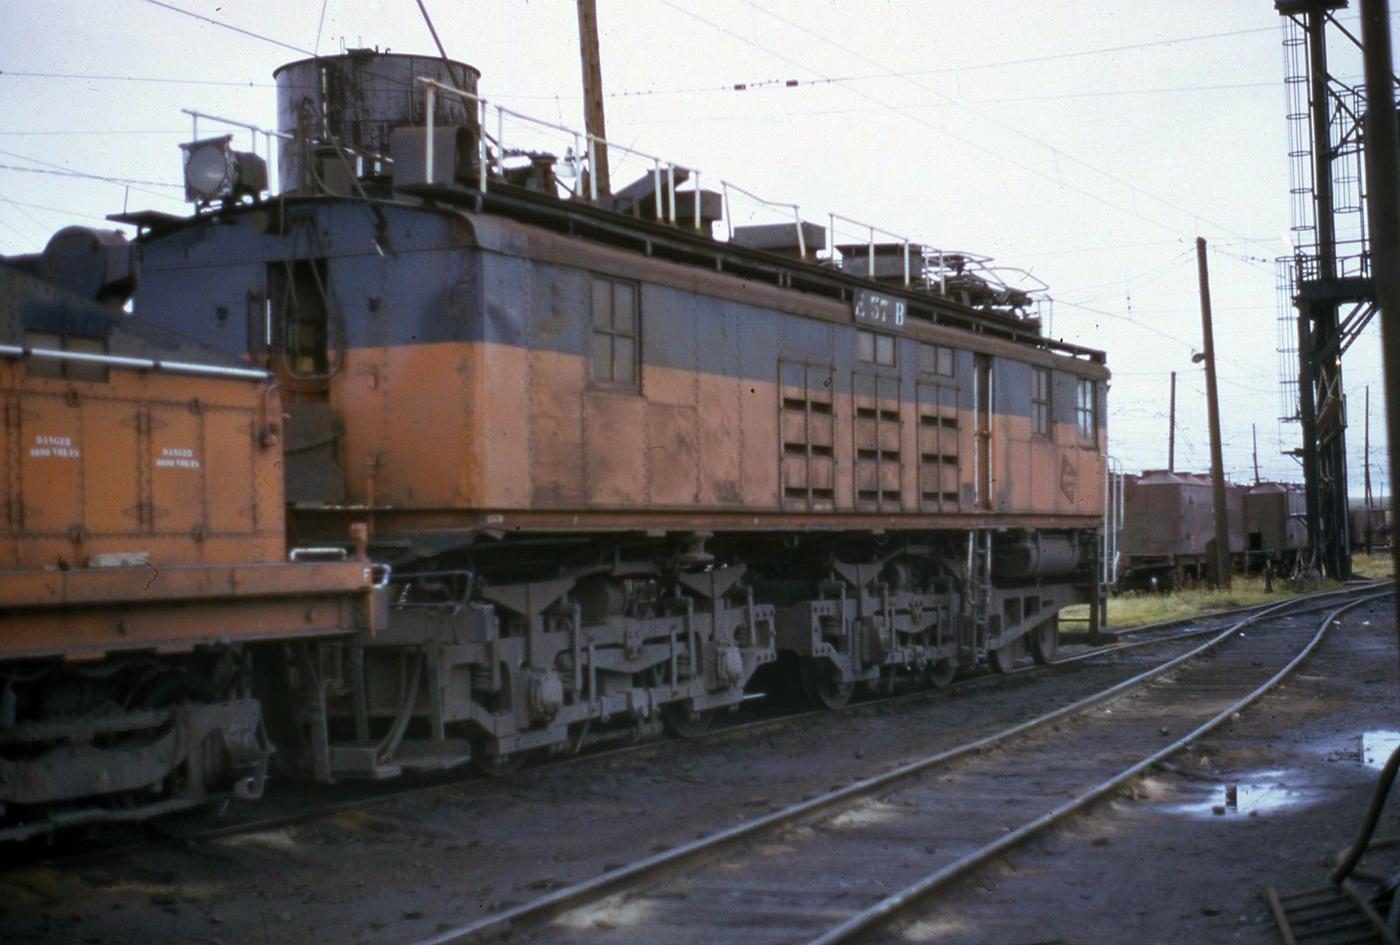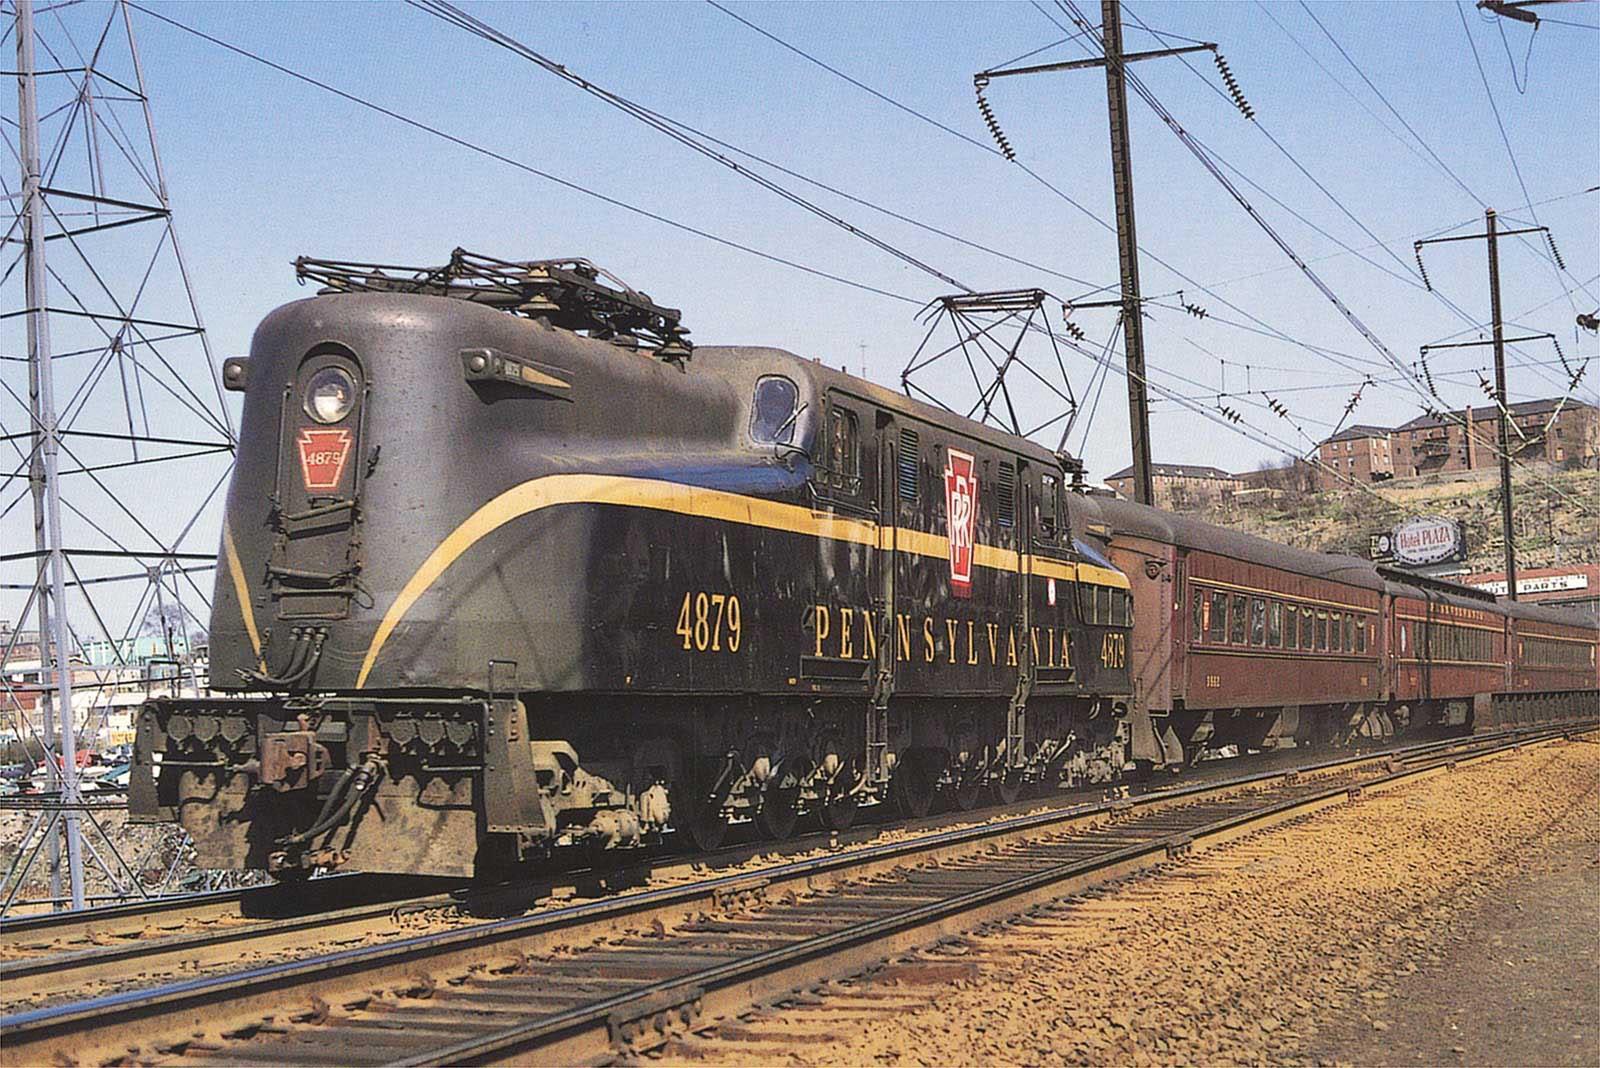The first image is the image on the left, the second image is the image on the right. For the images shown, is this caption "At least one of the trains is painted with the bottom half orange, and the top half brown." true? Answer yes or no. Yes. The first image is the image on the left, the second image is the image on the right. Analyze the images presented: Is the assertion "The train in the right image has a slightly pitched top like a peaked roof and has at least two distinct colors that run its length." valid? Answer yes or no. No. 